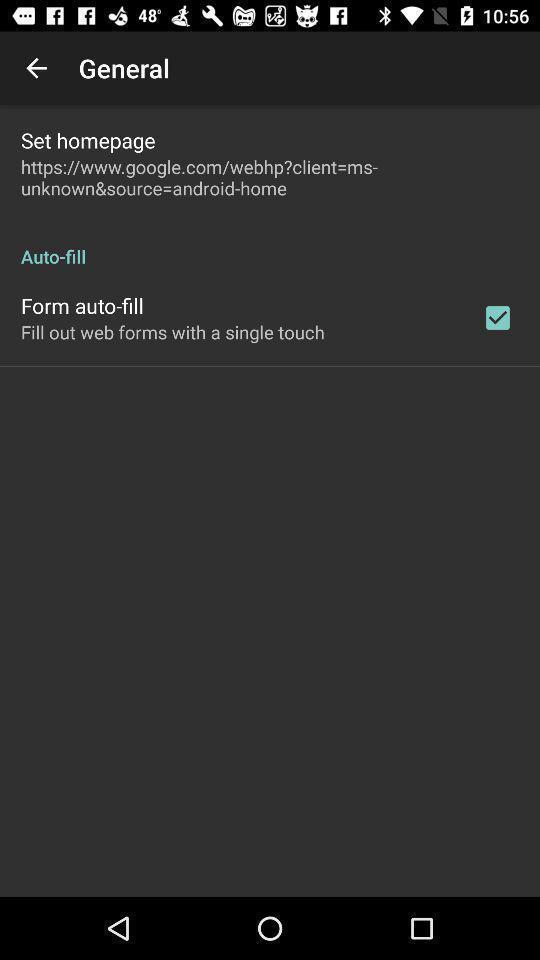Explain what's happening in this screen capture. Screen showing set homepage with auto fill option. 